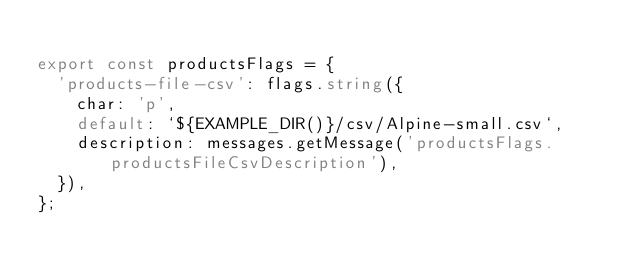<code> <loc_0><loc_0><loc_500><loc_500><_TypeScript_>
export const productsFlags = {
  'products-file-csv': flags.string({
    char: 'p',
    default: `${EXAMPLE_DIR()}/csv/Alpine-small.csv`,
    description: messages.getMessage('productsFlags.productsFileCsvDescription'),
  }),
};
</code> 